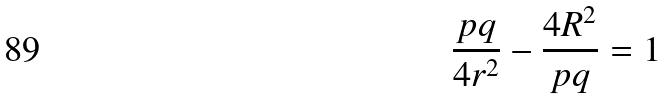<formula> <loc_0><loc_0><loc_500><loc_500>\frac { p q } { 4 r ^ { 2 } } - \frac { 4 R ^ { 2 } } { p q } = 1</formula> 